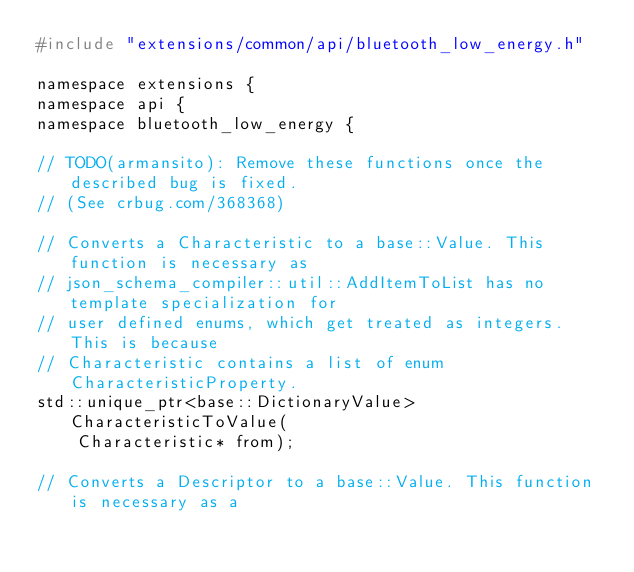<code> <loc_0><loc_0><loc_500><loc_500><_C_>#include "extensions/common/api/bluetooth_low_energy.h"

namespace extensions {
namespace api {
namespace bluetooth_low_energy {

// TODO(armansito): Remove these functions once the described bug is fixed.
// (See crbug.com/368368)

// Converts a Characteristic to a base::Value. This function is necessary as
// json_schema_compiler::util::AddItemToList has no template specialization for
// user defined enums, which get treated as integers. This is because
// Characteristic contains a list of enum CharacteristicProperty.
std::unique_ptr<base::DictionaryValue> CharacteristicToValue(
    Characteristic* from);

// Converts a Descriptor to a base::Value. This function is necessary as a</code> 